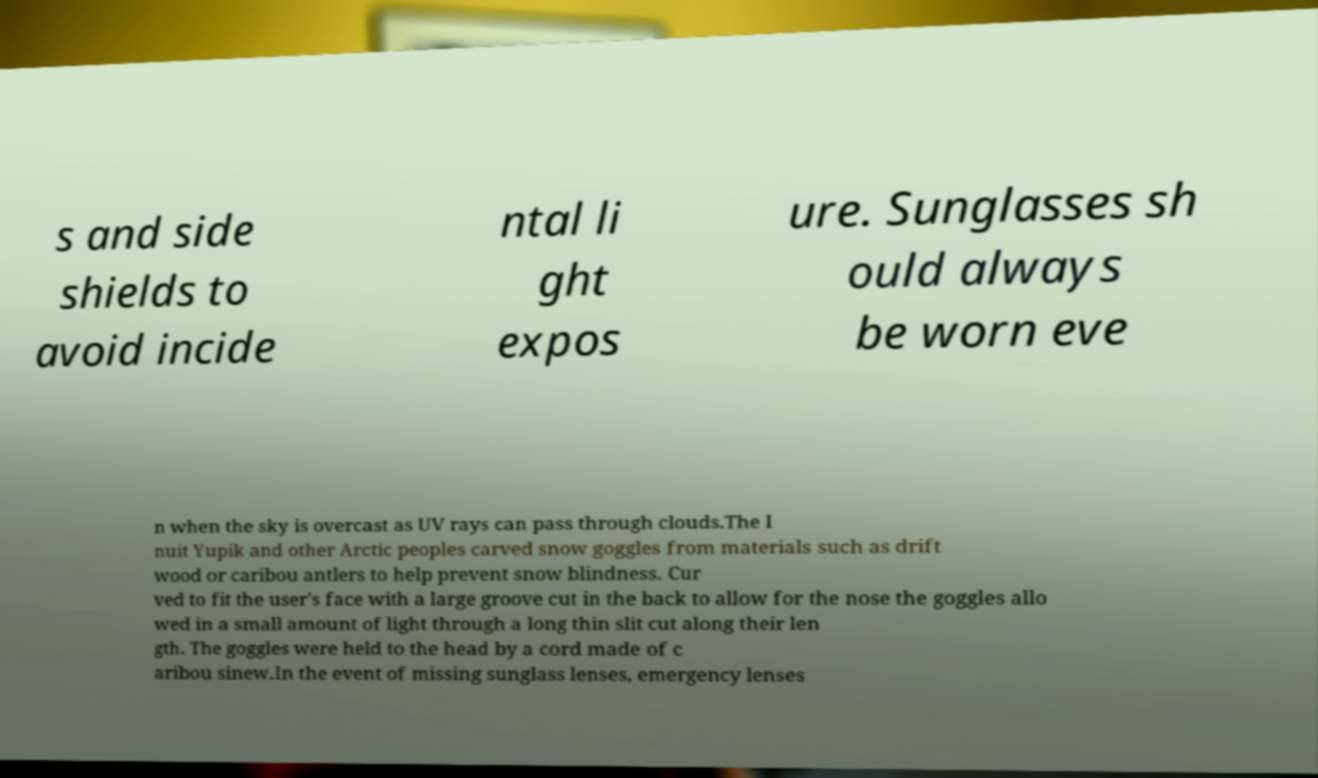Can you accurately transcribe the text from the provided image for me? s and side shields to avoid incide ntal li ght expos ure. Sunglasses sh ould always be worn eve n when the sky is overcast as UV rays can pass through clouds.The I nuit Yupik and other Arctic peoples carved snow goggles from materials such as drift wood or caribou antlers to help prevent snow blindness. Cur ved to fit the user's face with a large groove cut in the back to allow for the nose the goggles allo wed in a small amount of light through a long thin slit cut along their len gth. The goggles were held to the head by a cord made of c aribou sinew.In the event of missing sunglass lenses, emergency lenses 